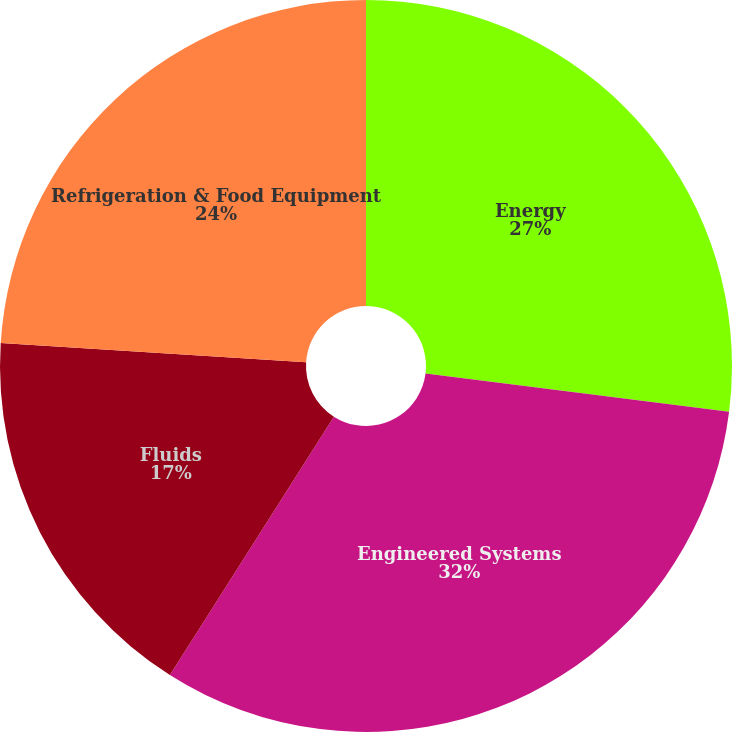Convert chart to OTSL. <chart><loc_0><loc_0><loc_500><loc_500><pie_chart><fcel>Energy<fcel>Engineered Systems<fcel>Fluids<fcel>Refrigeration & Food Equipment<nl><fcel>27.0%<fcel>32.0%<fcel>17.0%<fcel>24.0%<nl></chart> 